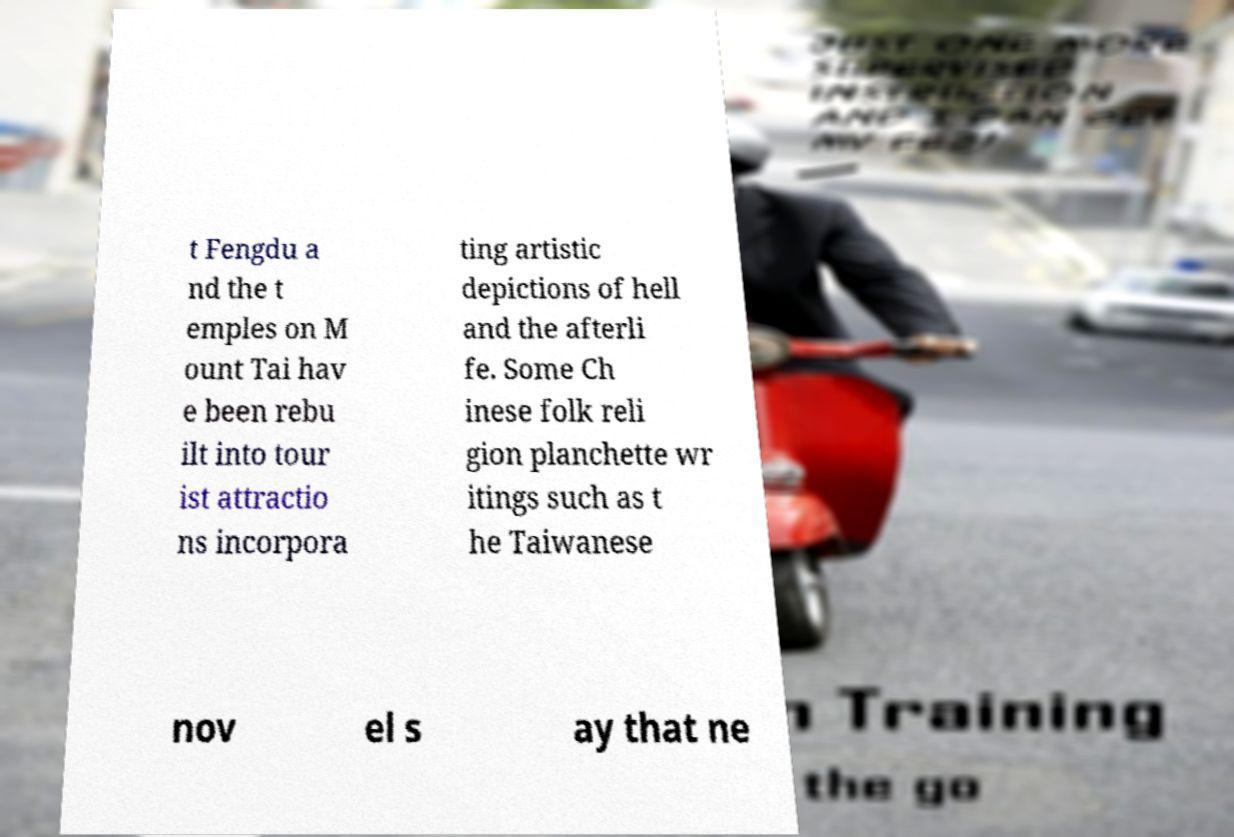Could you extract and type out the text from this image? t Fengdu a nd the t emples on M ount Tai hav e been rebu ilt into tour ist attractio ns incorpora ting artistic depictions of hell and the afterli fe. Some Ch inese folk reli gion planchette wr itings such as t he Taiwanese nov el s ay that ne 